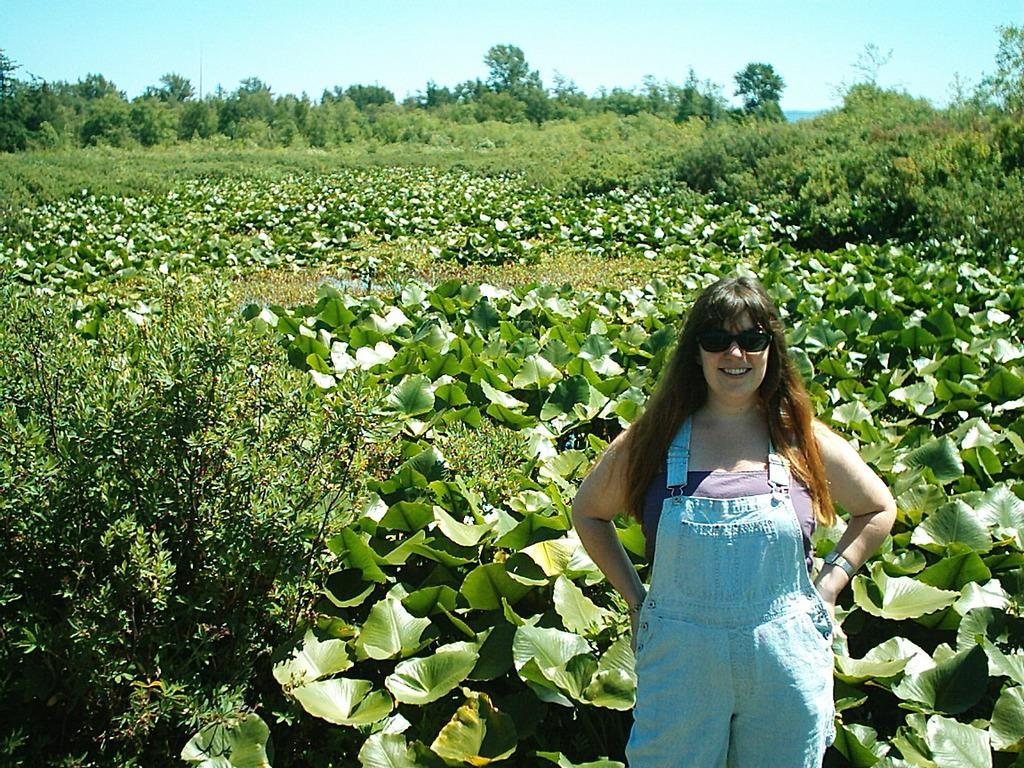Who is the main subject on the left side of the image? There is a lady with goggles on the left side of the image. What can be seen in the background behind the lady? There are many plants and trees behind the lady. What is visible at the top of the image? The sky is visible at the top of the image. How does the doll react to the earthquake in the image? There is no doll or earthquake present in the image. 